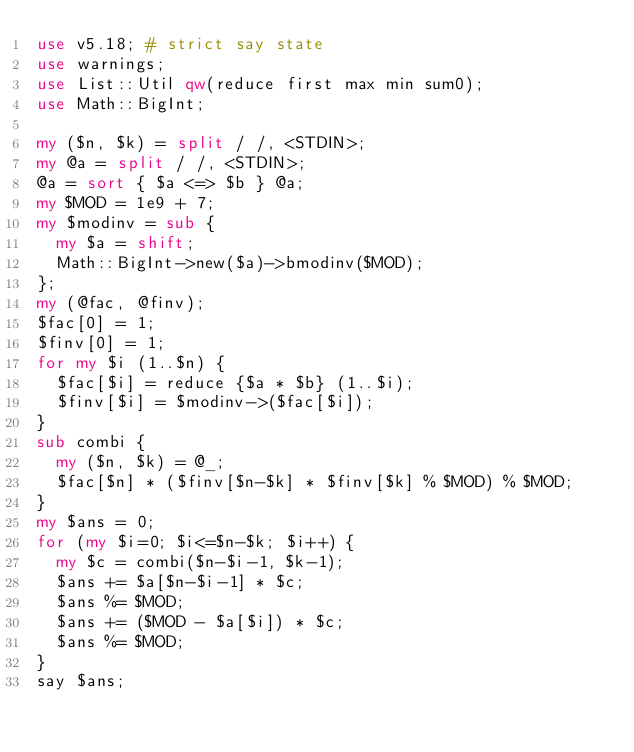Convert code to text. <code><loc_0><loc_0><loc_500><loc_500><_Perl_>use v5.18; # strict say state
use warnings;
use List::Util qw(reduce first max min sum0);
use Math::BigInt;

my ($n, $k) = split / /, <STDIN>;
my @a = split / /, <STDIN>;
@a = sort { $a <=> $b } @a;
my $MOD = 1e9 + 7;
my $modinv = sub {
  my $a = shift;
  Math::BigInt->new($a)->bmodinv($MOD);
};
my (@fac, @finv);
$fac[0] = 1;
$finv[0] = 1;
for my $i (1..$n) {
  $fac[$i] = reduce {$a * $b} (1..$i);
  $finv[$i] = $modinv->($fac[$i]);
}
sub combi {
  my ($n, $k) = @_;
  $fac[$n] * ($finv[$n-$k] * $finv[$k] % $MOD) % $MOD;
}
my $ans = 0;
for (my $i=0; $i<=$n-$k; $i++) {
  my $c = combi($n-$i-1, $k-1);
  $ans += $a[$n-$i-1] * $c;
  $ans %= $MOD;
  $ans += ($MOD - $a[$i]) * $c;
  $ans %= $MOD;
}
say $ans;</code> 